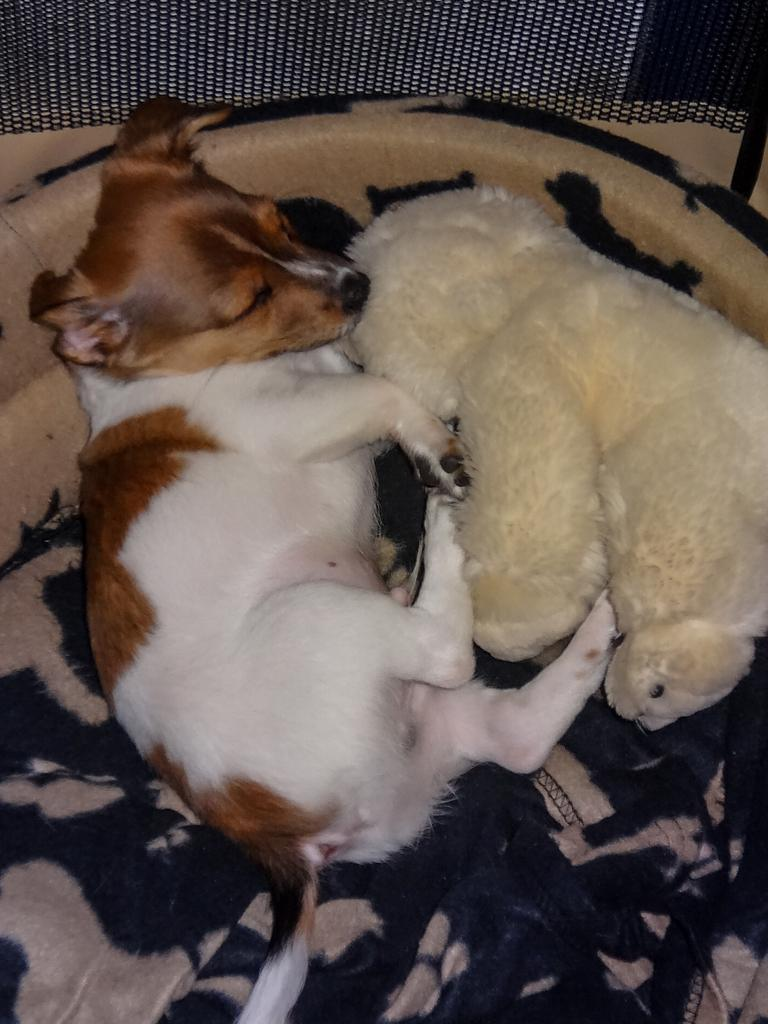What type of animal can be seen in the image? There is a dog in the image. What other object is present in the image? There is a teddy bear in the image. What is covering the dog in the image? There is a blanket in the image. What is the dog doing in the image? The dog is sleeping. What type of stitch is used to sew the dog's fur in the image? The image is a photograph, not a drawing or illustration, so there is no stitching involved in the dog's fur. 